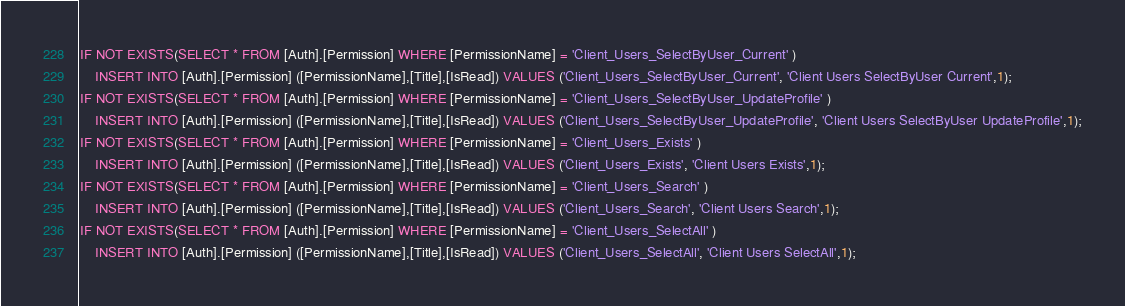<code> <loc_0><loc_0><loc_500><loc_500><_SQL_>IF NOT EXISTS(SELECT * FROM [Auth].[Permission] WHERE [PermissionName] = 'Client_Users_SelectByUser_Current' )
	INSERT INTO [Auth].[Permission] ([PermissionName],[Title],[IsRead]) VALUES ('Client_Users_SelectByUser_Current', 'Client Users SelectByUser Current',1);
IF NOT EXISTS(SELECT * FROM [Auth].[Permission] WHERE [PermissionName] = 'Client_Users_SelectByUser_UpdateProfile' )
	INSERT INTO [Auth].[Permission] ([PermissionName],[Title],[IsRead]) VALUES ('Client_Users_SelectByUser_UpdateProfile', 'Client Users SelectByUser UpdateProfile',1);
IF NOT EXISTS(SELECT * FROM [Auth].[Permission] WHERE [PermissionName] = 'Client_Users_Exists' )
	INSERT INTO [Auth].[Permission] ([PermissionName],[Title],[IsRead]) VALUES ('Client_Users_Exists', 'Client Users Exists',1);
IF NOT EXISTS(SELECT * FROM [Auth].[Permission] WHERE [PermissionName] = 'Client_Users_Search' )
	INSERT INTO [Auth].[Permission] ([PermissionName],[Title],[IsRead]) VALUES ('Client_Users_Search', 'Client Users Search',1);
IF NOT EXISTS(SELECT * FROM [Auth].[Permission] WHERE [PermissionName] = 'Client_Users_SelectAll' )
	INSERT INTO [Auth].[Permission] ([PermissionName],[Title],[IsRead]) VALUES ('Client_Users_SelectAll', 'Client Users SelectAll',1);
</code> 